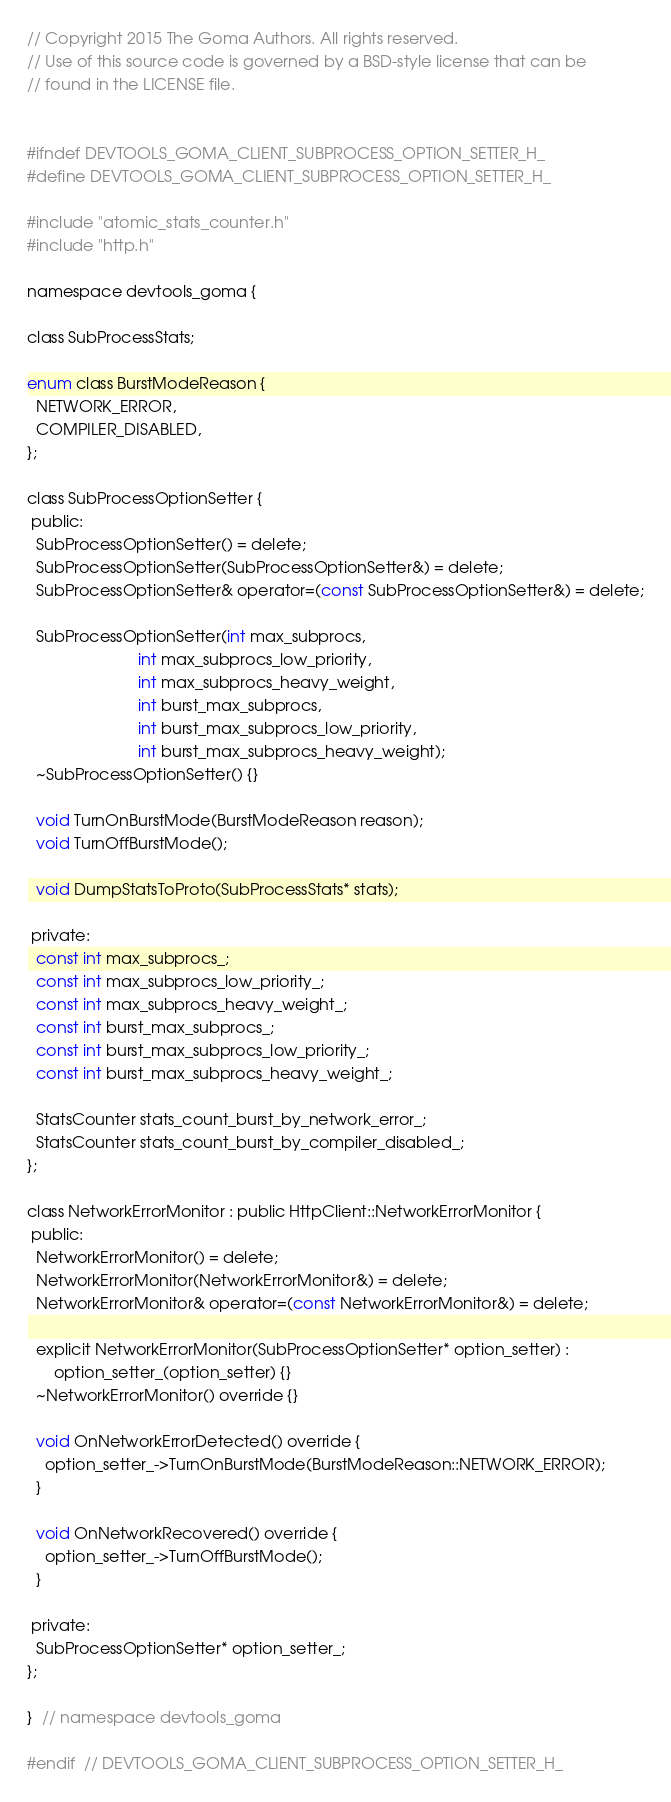Convert code to text. <code><loc_0><loc_0><loc_500><loc_500><_C_>// Copyright 2015 The Goma Authors. All rights reserved.
// Use of this source code is governed by a BSD-style license that can be
// found in the LICENSE file.


#ifndef DEVTOOLS_GOMA_CLIENT_SUBPROCESS_OPTION_SETTER_H_
#define DEVTOOLS_GOMA_CLIENT_SUBPROCESS_OPTION_SETTER_H_

#include "atomic_stats_counter.h"
#include "http.h"

namespace devtools_goma {

class SubProcessStats;

enum class BurstModeReason {
  NETWORK_ERROR,
  COMPILER_DISABLED,
};

class SubProcessOptionSetter {
 public:
  SubProcessOptionSetter() = delete;
  SubProcessOptionSetter(SubProcessOptionSetter&) = delete;
  SubProcessOptionSetter& operator=(const SubProcessOptionSetter&) = delete;

  SubProcessOptionSetter(int max_subprocs,
                         int max_subprocs_low_priority,
                         int max_subprocs_heavy_weight,
                         int burst_max_subprocs,
                         int burst_max_subprocs_low_priority,
                         int burst_max_subprocs_heavy_weight);
  ~SubProcessOptionSetter() {}

  void TurnOnBurstMode(BurstModeReason reason);
  void TurnOffBurstMode();

  void DumpStatsToProto(SubProcessStats* stats);

 private:
  const int max_subprocs_;
  const int max_subprocs_low_priority_;
  const int max_subprocs_heavy_weight_;
  const int burst_max_subprocs_;
  const int burst_max_subprocs_low_priority_;
  const int burst_max_subprocs_heavy_weight_;

  StatsCounter stats_count_burst_by_network_error_;
  StatsCounter stats_count_burst_by_compiler_disabled_;
};

class NetworkErrorMonitor : public HttpClient::NetworkErrorMonitor {
 public:
  NetworkErrorMonitor() = delete;
  NetworkErrorMonitor(NetworkErrorMonitor&) = delete;
  NetworkErrorMonitor& operator=(const NetworkErrorMonitor&) = delete;

  explicit NetworkErrorMonitor(SubProcessOptionSetter* option_setter) :
      option_setter_(option_setter) {}
  ~NetworkErrorMonitor() override {}

  void OnNetworkErrorDetected() override {
    option_setter_->TurnOnBurstMode(BurstModeReason::NETWORK_ERROR);
  }

  void OnNetworkRecovered() override {
    option_setter_->TurnOffBurstMode();
  }

 private:
  SubProcessOptionSetter* option_setter_;
};

}  // namespace devtools_goma

#endif  // DEVTOOLS_GOMA_CLIENT_SUBPROCESS_OPTION_SETTER_H_
</code> 